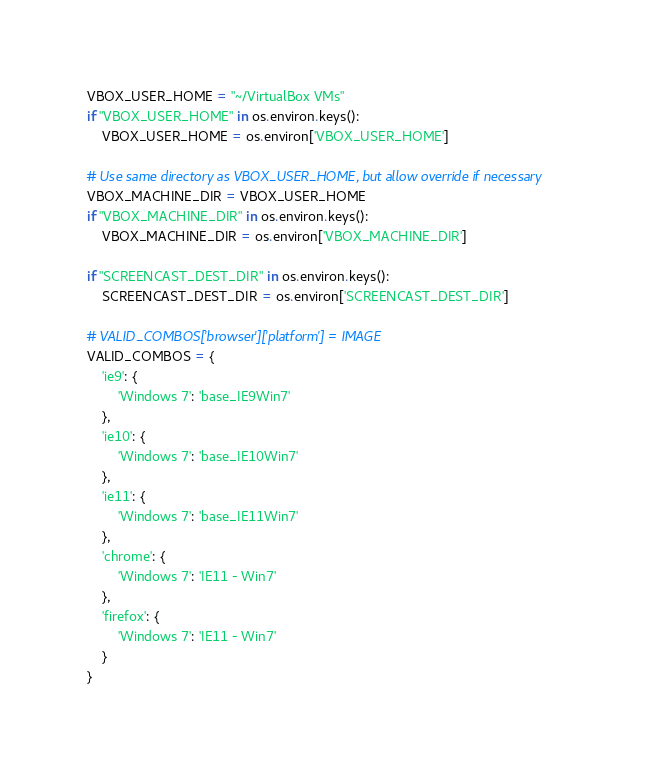Convert code to text. <code><loc_0><loc_0><loc_500><loc_500><_Python_>
VBOX_USER_HOME = "~/VirtualBox VMs"
if "VBOX_USER_HOME" in os.environ.keys():
    VBOX_USER_HOME = os.environ['VBOX_USER_HOME']

# Use same directory as VBOX_USER_HOME, but allow override if necessary
VBOX_MACHINE_DIR = VBOX_USER_HOME
if "VBOX_MACHINE_DIR" in os.environ.keys():
    VBOX_MACHINE_DIR = os.environ['VBOX_MACHINE_DIR']

if "SCREENCAST_DEST_DIR" in os.environ.keys():
    SCREENCAST_DEST_DIR = os.environ['SCREENCAST_DEST_DIR']

# VALID_COMBOS['browser']['platform'] = IMAGE
VALID_COMBOS = {
    'ie9': {
        'Windows 7': 'base_IE9Win7'
    },
    'ie10': {
        'Windows 7': 'base_IE10Win7'
    },
    'ie11': {
        'Windows 7': 'base_IE11Win7'
    },
    'chrome': {
        'Windows 7': 'IE11 - Win7'
    },
    'firefox': {
        'Windows 7': 'IE11 - Win7'
    }
}
</code> 